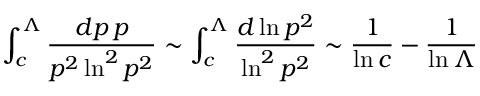<formula> <loc_0><loc_0><loc_500><loc_500>\int _ { c } ^ { \Lambda } { \frac { d p \, p } { p ^ { 2 } \ln ^ { 2 } p ^ { 2 } } } \sim \int _ { c } ^ { \Lambda } { \frac { d \ln p ^ { 2 } } { \ln ^ { 2 } p ^ { 2 } } } \sim { \frac { 1 } { \ln c } } - { \frac { 1 } { \ln \Lambda } }</formula> 